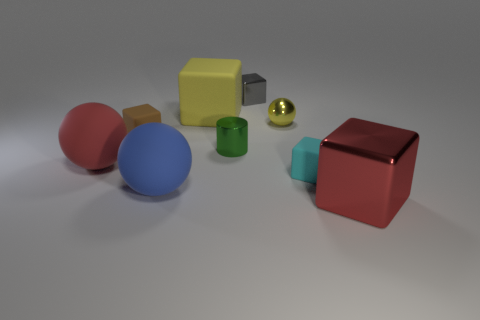Subtract all red metal blocks. How many blocks are left? 4 Subtract all yellow cubes. How many cubes are left? 4 Subtract 2 cubes. How many cubes are left? 3 Add 1 big red rubber balls. How many objects exist? 10 Subtract all purple spheres. Subtract all red cylinders. How many spheres are left? 3 Subtract all balls. How many objects are left? 6 Add 5 yellow cubes. How many yellow cubes are left? 6 Add 2 small shiny cubes. How many small shiny cubes exist? 3 Subtract 0 gray spheres. How many objects are left? 9 Subtract all large metallic cubes. Subtract all tiny cyan objects. How many objects are left? 7 